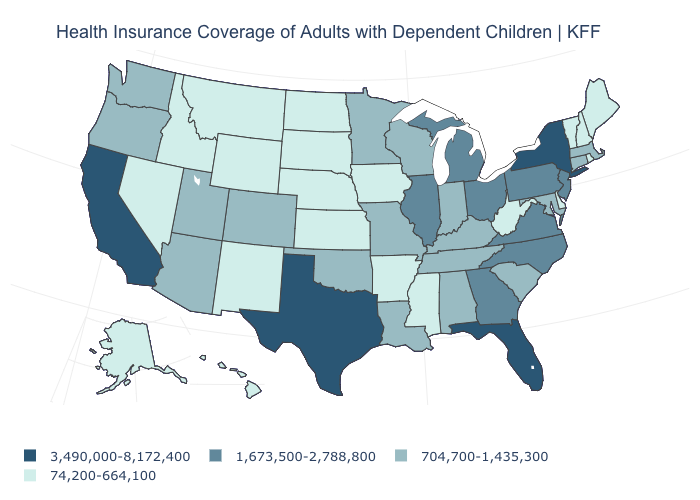Among the states that border Kentucky , does Virginia have the highest value?
Quick response, please. Yes. What is the value of New York?
Be succinct. 3,490,000-8,172,400. What is the highest value in the West ?
Quick response, please. 3,490,000-8,172,400. What is the value of Virginia?
Quick response, please. 1,673,500-2,788,800. What is the lowest value in the West?
Short answer required. 74,200-664,100. What is the lowest value in the USA?
Short answer required. 74,200-664,100. What is the value of Kentucky?
Answer briefly. 704,700-1,435,300. What is the lowest value in states that border Washington?
Quick response, please. 74,200-664,100. Does New York have the same value as Kansas?
Keep it brief. No. What is the value of Rhode Island?
Answer briefly. 74,200-664,100. What is the highest value in the USA?
Answer briefly. 3,490,000-8,172,400. Among the states that border Missouri , which have the lowest value?
Quick response, please. Arkansas, Iowa, Kansas, Nebraska. Name the states that have a value in the range 3,490,000-8,172,400?
Short answer required. California, Florida, New York, Texas. Does Arkansas have the highest value in the USA?
Write a very short answer. No. What is the value of Michigan?
Concise answer only. 1,673,500-2,788,800. 